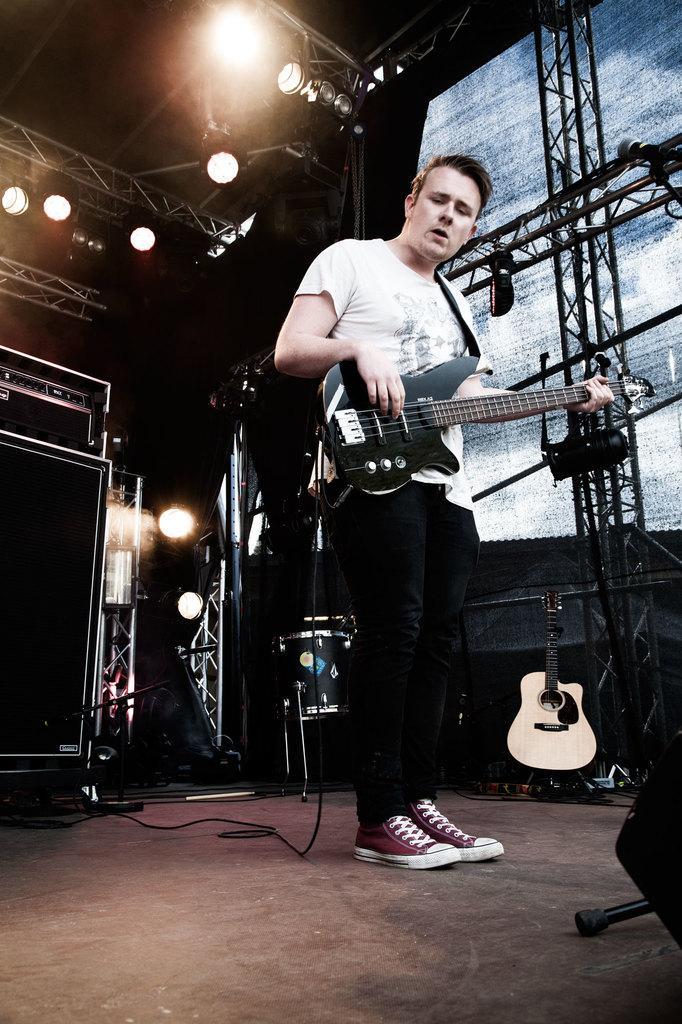In one or two sentences, can you explain what this image depicts? The image consists of a guy playing guitar on a stage and on ceiling there are many lights. 